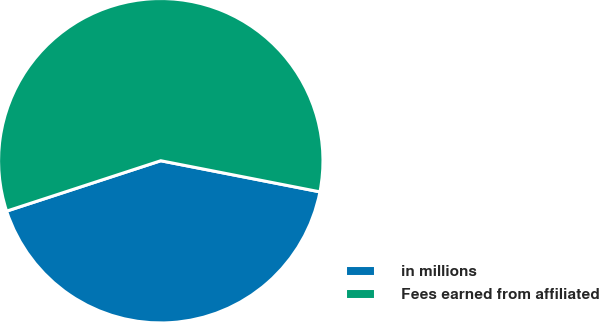Convert chart. <chart><loc_0><loc_0><loc_500><loc_500><pie_chart><fcel>in millions<fcel>Fees earned from affiliated<nl><fcel>41.9%<fcel>58.1%<nl></chart> 